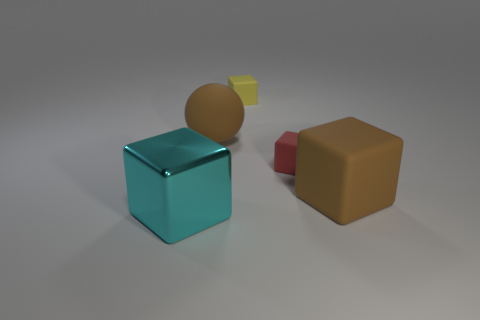Is there anything else of the same color as the large shiny thing?
Your answer should be compact. No. There is a matte cube right of the small red matte cube; is its size the same as the cube left of the yellow thing?
Your answer should be compact. Yes. There is a large brown matte thing left of the large cube that is on the right side of the metal thing; what shape is it?
Ensure brevity in your answer.  Sphere. Do the yellow block and the red matte block that is right of the large brown rubber ball have the same size?
Provide a short and direct response. Yes. What is the size of the cube behind the big brown rubber object left of the big block that is behind the shiny object?
Provide a short and direct response. Small. What number of objects are either large things on the right side of the cyan metal cube or brown spheres?
Provide a short and direct response. 2. What number of cyan cubes are right of the large cube on the left side of the brown block?
Make the answer very short. 0. Is the number of cyan metallic objects that are behind the small yellow object greater than the number of small brown cylinders?
Offer a very short reply. No. What is the size of the thing that is to the left of the tiny yellow rubber cube and behind the big brown rubber cube?
Offer a very short reply. Large. There is a large thing that is in front of the sphere and behind the big cyan metallic block; what shape is it?
Ensure brevity in your answer.  Cube. 